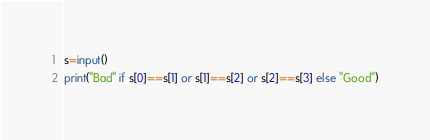<code> <loc_0><loc_0><loc_500><loc_500><_Python_>s=input()
print("Bad" if s[0]==s[1] or s[1]==s[2] or s[2]==s[3] else "Good")</code> 